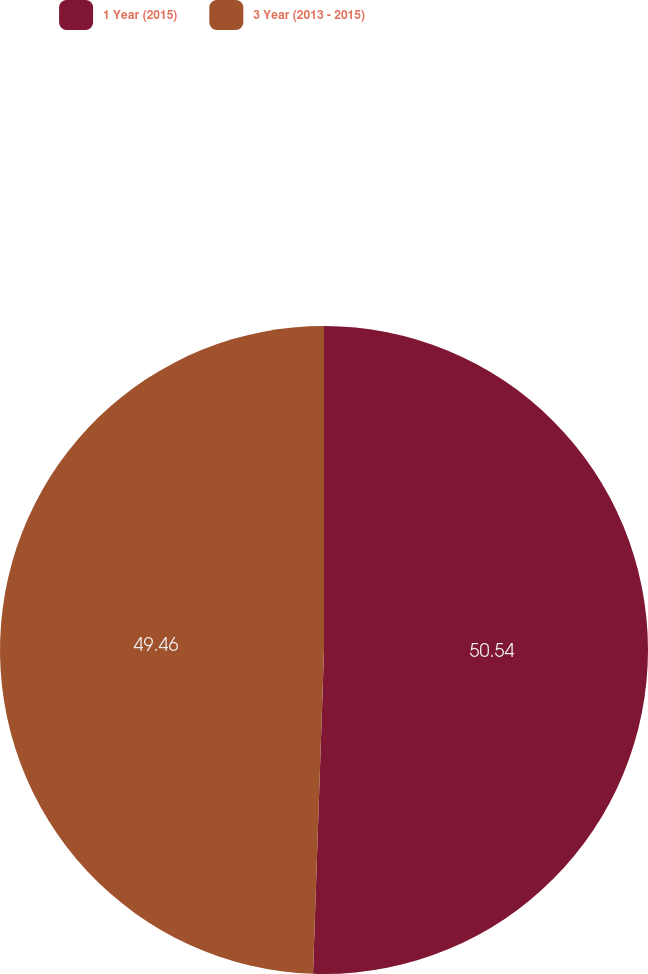Convert chart. <chart><loc_0><loc_0><loc_500><loc_500><pie_chart><fcel>1 Year (2015)<fcel>3 Year (2013 - 2015)<nl><fcel>50.54%<fcel>49.46%<nl></chart> 